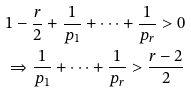<formula> <loc_0><loc_0><loc_500><loc_500>& 1 - \frac { r } { 2 } + \frac { 1 } { p _ { 1 } } + \cdots + \frac { 1 } { p _ { r } } > 0 \\ & \Rightarrow \frac { 1 } { p _ { 1 } } + \cdots + \frac { 1 } { p _ { r } } > \frac { r - 2 } { 2 }</formula> 